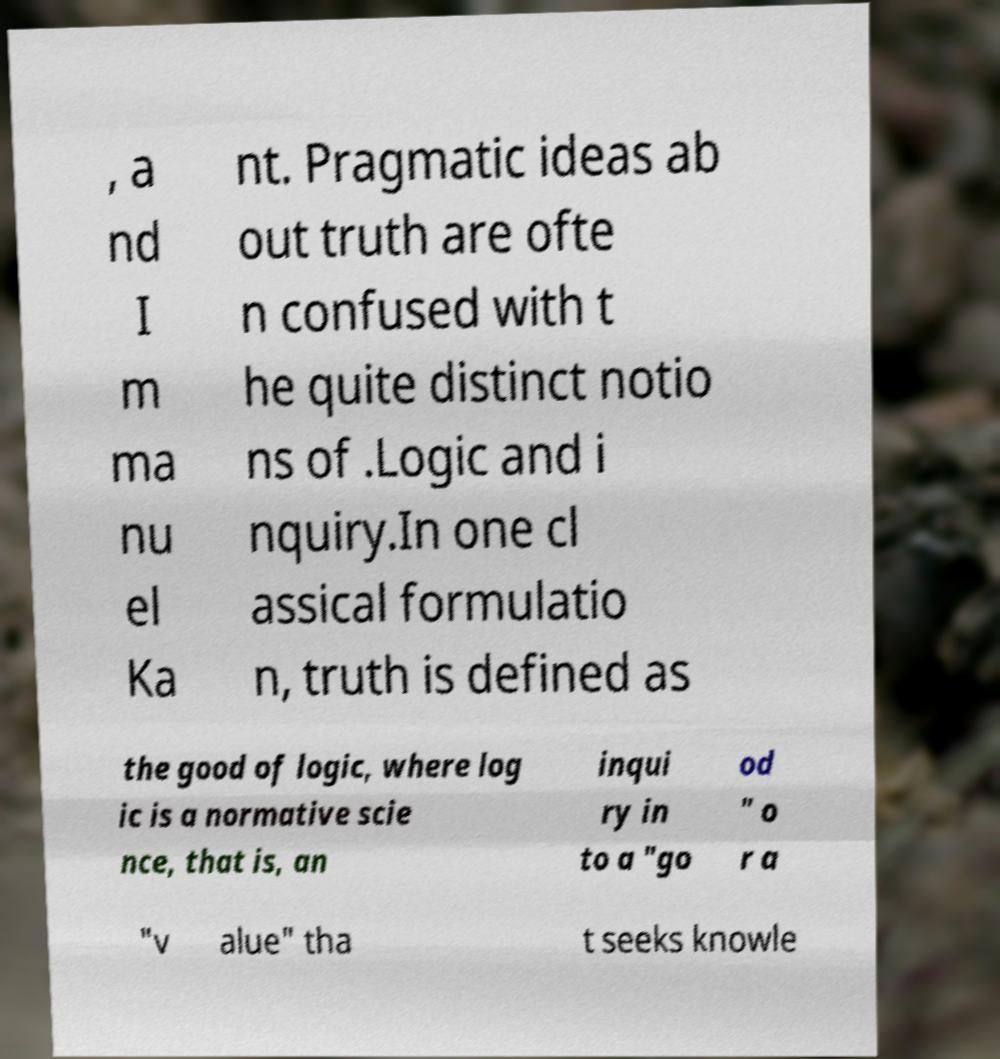Could you assist in decoding the text presented in this image and type it out clearly? , a nd I m ma nu el Ka nt. Pragmatic ideas ab out truth are ofte n confused with t he quite distinct notio ns of .Logic and i nquiry.In one cl assical formulatio n, truth is defined as the good of logic, where log ic is a normative scie nce, that is, an inqui ry in to a "go od " o r a "v alue" tha t seeks knowle 